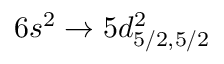Convert formula to latex. <formula><loc_0><loc_0><loc_500><loc_500>6 s ^ { 2 } \rightarrow 5 d _ { 5 / 2 , 5 / 2 } ^ { 2 }</formula> 